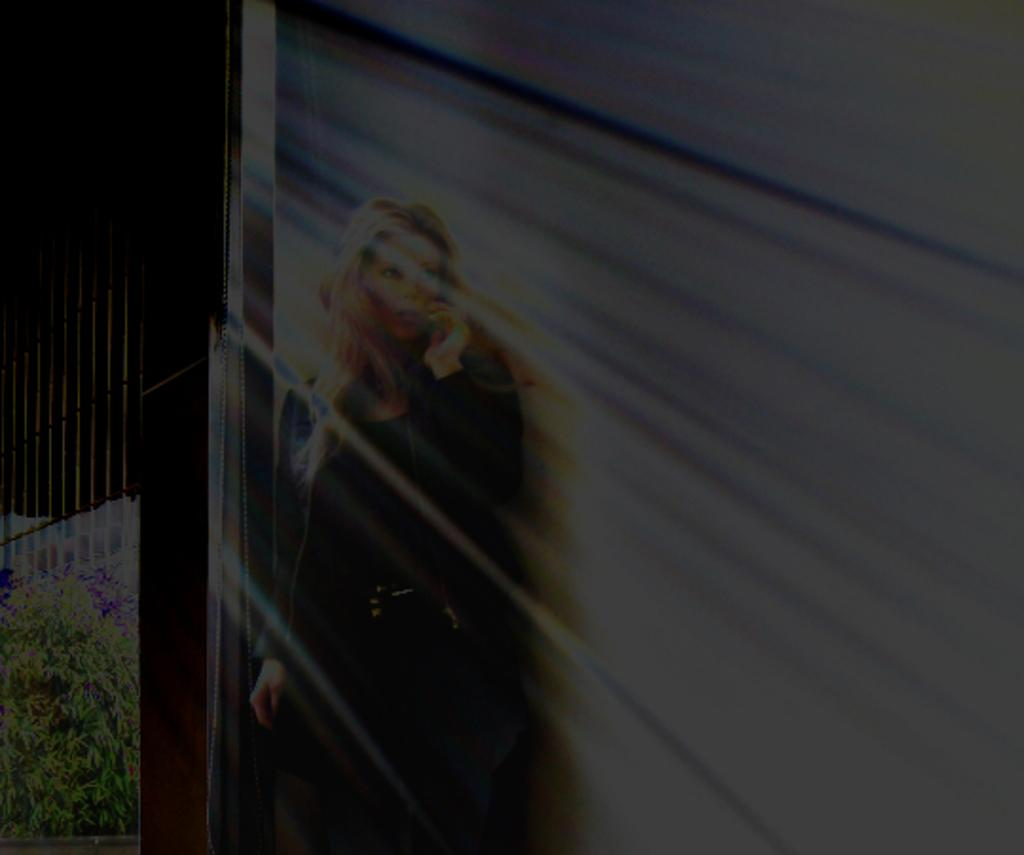What is the overall tone of the image? The image is dark. Who is present in the image? There is a woman in the image. What is the woman wearing? The woman is wearing a black jacket and dress. What is the woman holding in the image? The woman is holding a mobile phone. What is the woman's posture in the image? The woman is standing in the image. What type of vegetation can be seen in the image? There are plants visible in the image. Can you tell me how many boards are visible in the image? There are no boards present in the image. Is the woman swimming in the image? The woman is not swimming in the image; she is standing. 